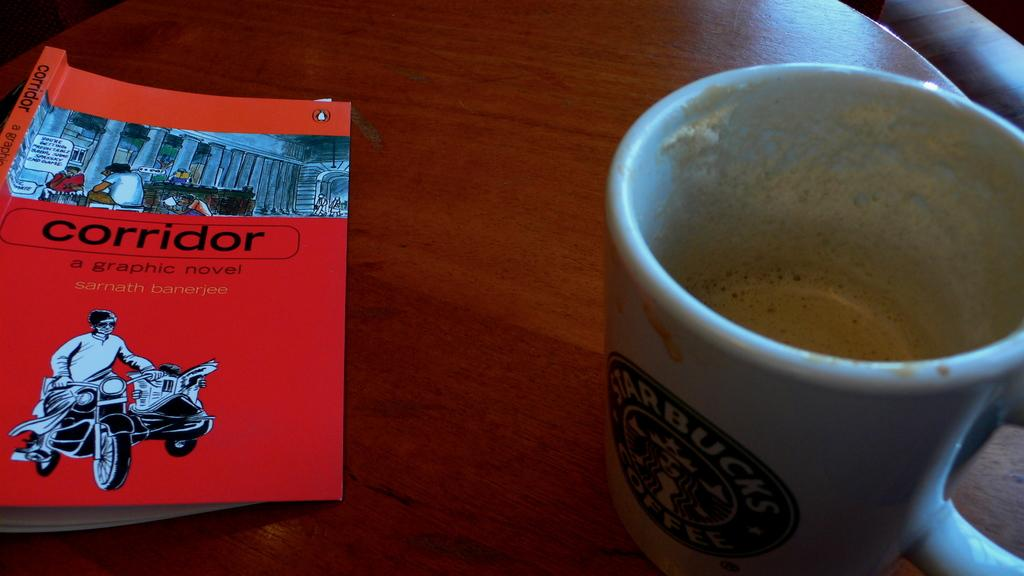<image>
Relay a brief, clear account of the picture shown. A Starbucks half-filled coffee mug sits by a red book called "corridor". 